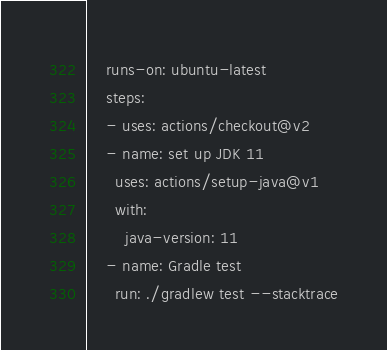Convert code to text. <code><loc_0><loc_0><loc_500><loc_500><_YAML_>    runs-on: ubuntu-latest
    steps:
    - uses: actions/checkout@v2
    - name: set up JDK 11
      uses: actions/setup-java@v1
      with:
        java-version: 11
    - name: Gradle test
      run: ./gradlew test --stacktrace
</code> 